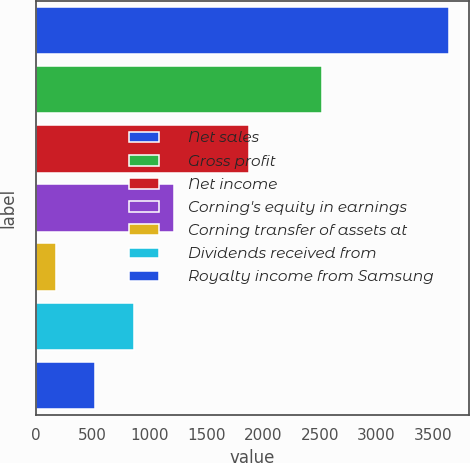<chart> <loc_0><loc_0><loc_500><loc_500><bar_chart><fcel>Net sales<fcel>Gross profit<fcel>Net income<fcel>Corning's equity in earnings<fcel>Corning transfer of assets at<fcel>Dividends received from<fcel>Royalty income from Samsung<nl><fcel>3636<fcel>2521<fcel>1874<fcel>1211.9<fcel>173<fcel>865.6<fcel>519.3<nl></chart> 